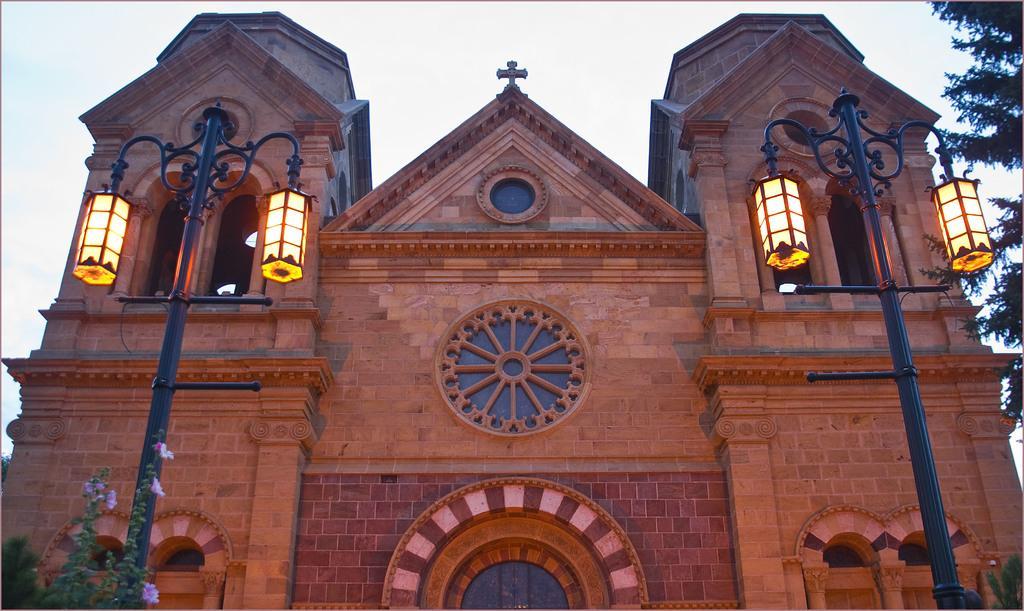Please provide a concise description of this image. This image consists of a building in brown color along with windows. On the left and right, we can see the poles along with lights. On the left, there is a small plant. On the right, there is a tree. At the top, there is sky. 